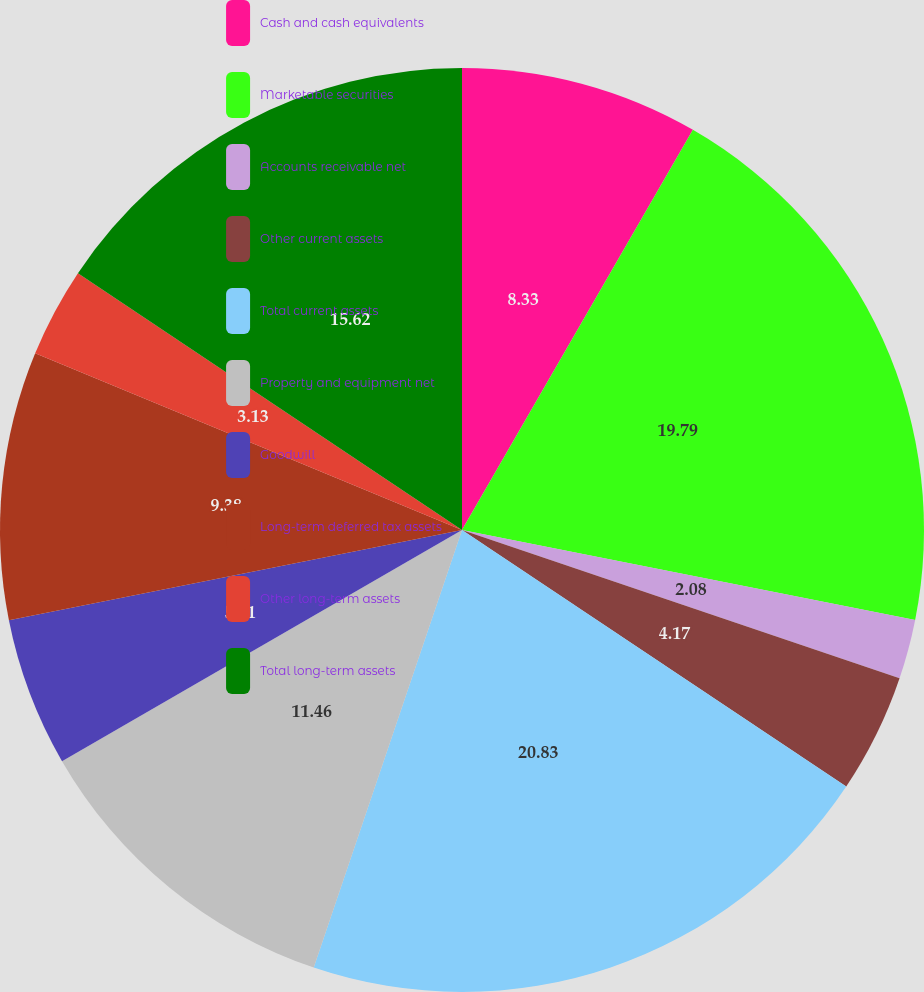Convert chart. <chart><loc_0><loc_0><loc_500><loc_500><pie_chart><fcel>Cash and cash equivalents<fcel>Marketable securities<fcel>Accounts receivable net<fcel>Other current assets<fcel>Total current assets<fcel>Property and equipment net<fcel>Goodwill<fcel>Long-term deferred tax assets<fcel>Other long-term assets<fcel>Total long-term assets<nl><fcel>8.33%<fcel>19.79%<fcel>2.08%<fcel>4.17%<fcel>20.83%<fcel>11.46%<fcel>5.21%<fcel>9.38%<fcel>3.13%<fcel>15.62%<nl></chart> 